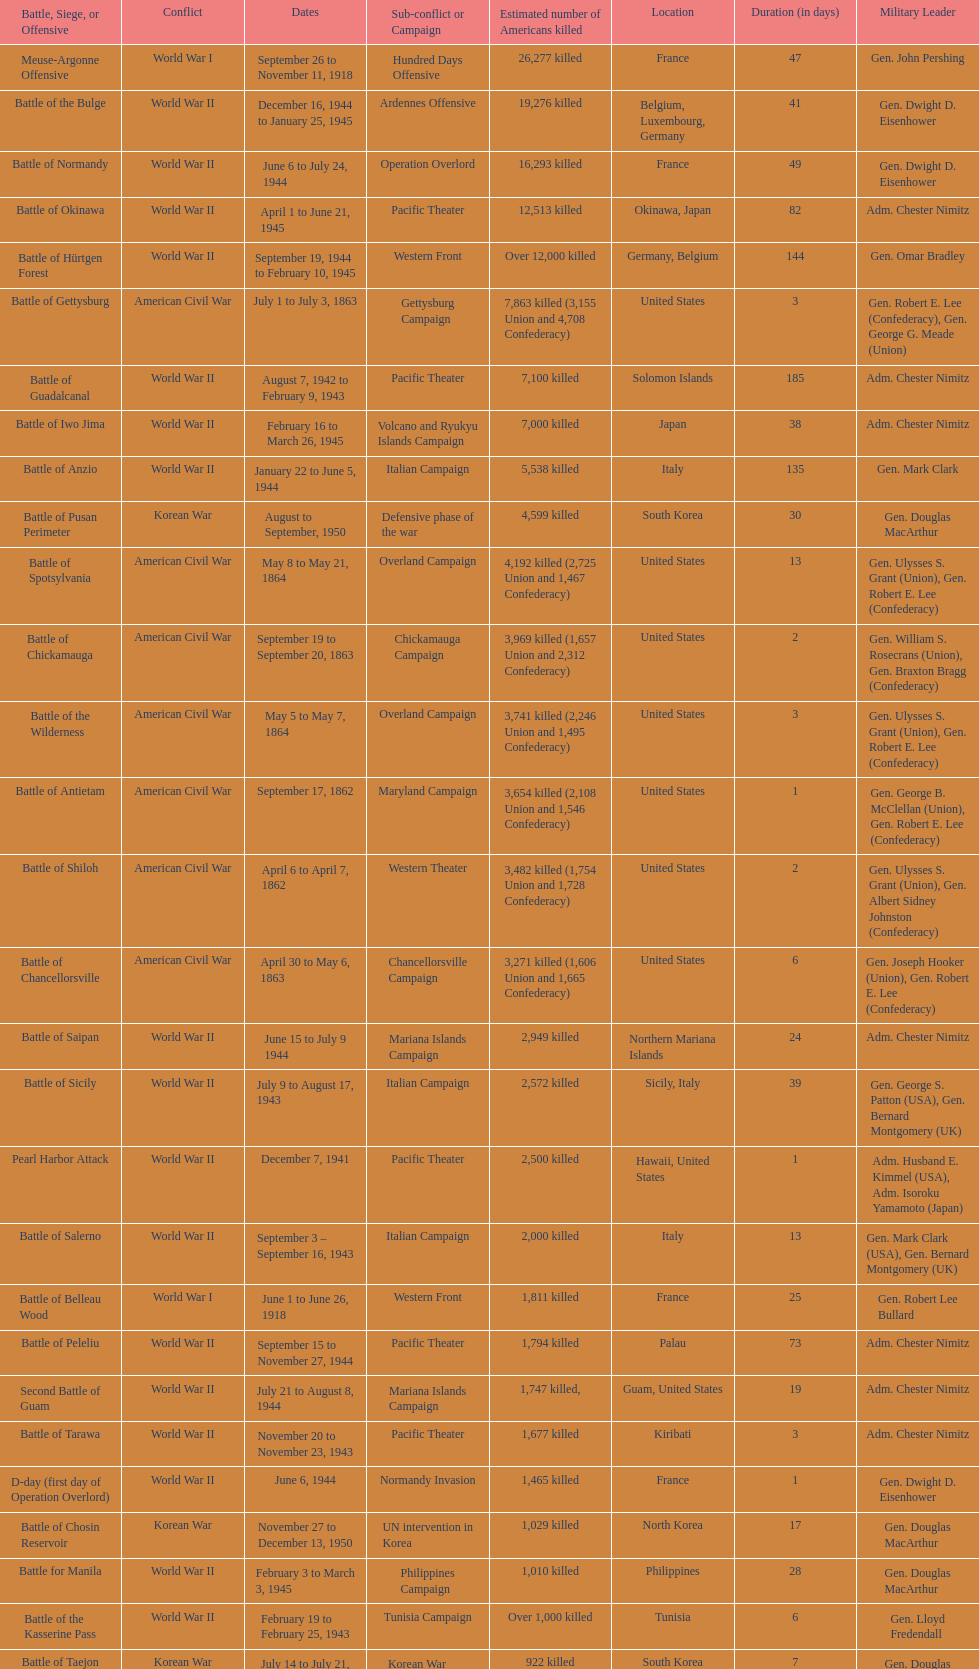How many battles resulted between 3,000 and 4,200 estimated americans killed? 6. 